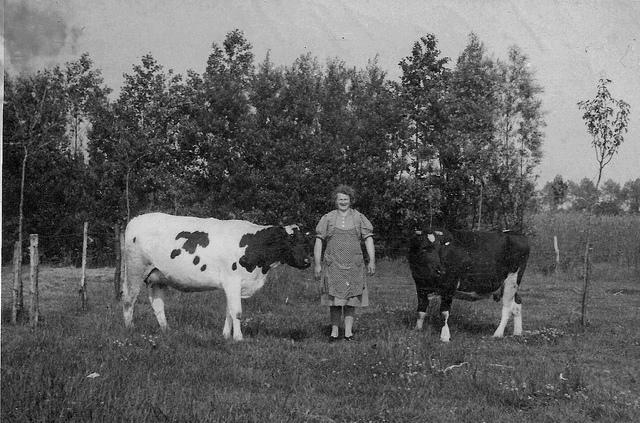What is the woman's orientation in relation to the cows? between them 